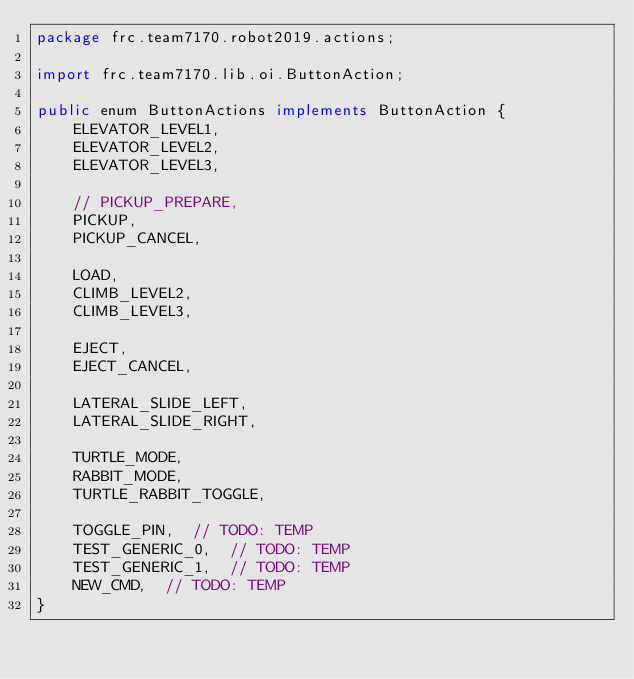Convert code to text. <code><loc_0><loc_0><loc_500><loc_500><_Java_>package frc.team7170.robot2019.actions;

import frc.team7170.lib.oi.ButtonAction;

public enum ButtonActions implements ButtonAction {
    ELEVATOR_LEVEL1,
    ELEVATOR_LEVEL2,
    ELEVATOR_LEVEL3,

    // PICKUP_PREPARE,
    PICKUP,
    PICKUP_CANCEL,

    LOAD,
    CLIMB_LEVEL2,
    CLIMB_LEVEL3,

    EJECT,
    EJECT_CANCEL,

    LATERAL_SLIDE_LEFT,
    LATERAL_SLIDE_RIGHT,

    TURTLE_MODE,
    RABBIT_MODE,
    TURTLE_RABBIT_TOGGLE,

    TOGGLE_PIN,  // TODO: TEMP
    TEST_GENERIC_0,  // TODO: TEMP
    TEST_GENERIC_1,  // TODO: TEMP
    NEW_CMD,  // TODO: TEMP
}
</code> 